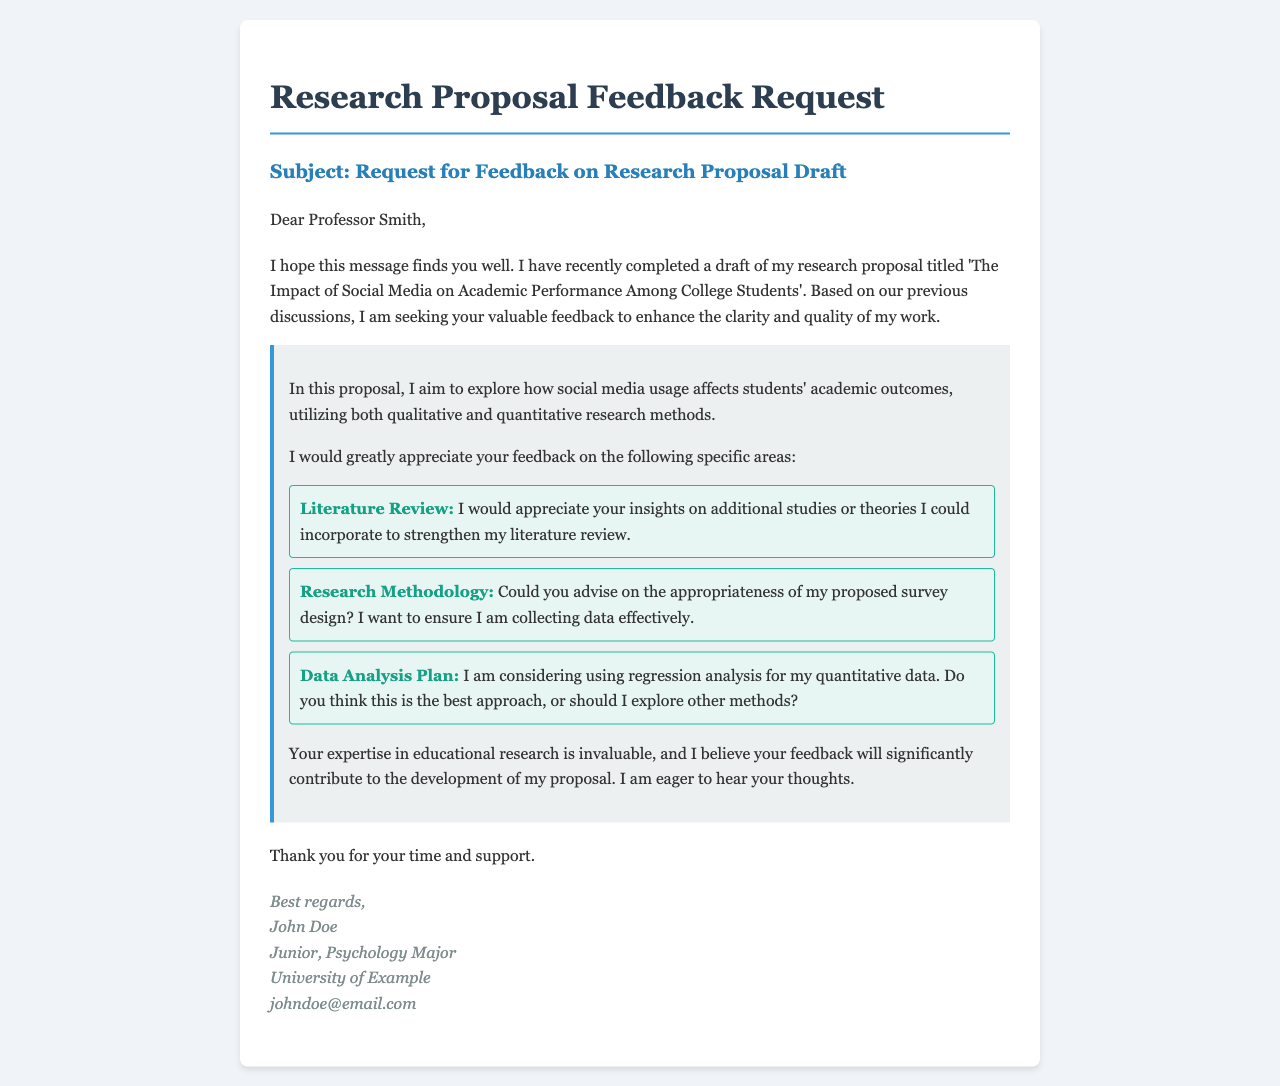What is the title of the research proposal? The title of the research proposal is mentioned early in the email as 'The Impact of Social Media on Academic Performance Among College Students'.
Answer: The Impact of Social Media on Academic Performance Among College Students Who is the recipient of the email? The recipient's name is stated in the greeting section of the email.
Answer: Professor Smith What area does the proposal focus on? The proposal focuses on exploring how social media usage affects students' academic outcomes.
Answer: Social media usage and academic outcomes What type of research methods is proposed? The email specifies the types of research methods that will be used in the proposal.
Answer: Qualitative and quantitative research methods What is one specific area for feedback requested by the sender? The sender lists specific areas they would like feedback on, one of which is the literature review.
Answer: Literature Review What methodology does the sender inquire about? The sender asks for advice on the appropriateness of their proposed survey design for collecting data.
Answer: Proposed survey design Which data analysis method is being considered? The sender mentions a specific data analysis method they are considering for their quantitative data.
Answer: Regression analysis What is the sender's major? The sender's major is included in the signature section of the email.
Answer: Psychology Major 